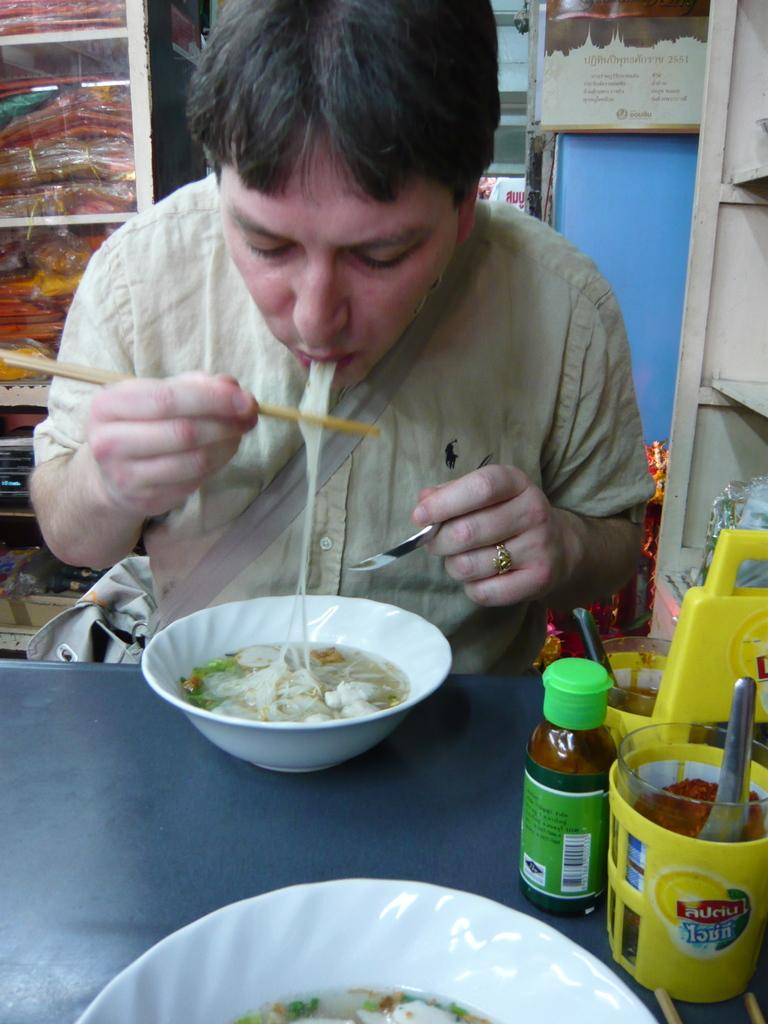<image>
Write a terse but informative summary of the picture. A man eating soup with condiments on a table including one called Auciu. 